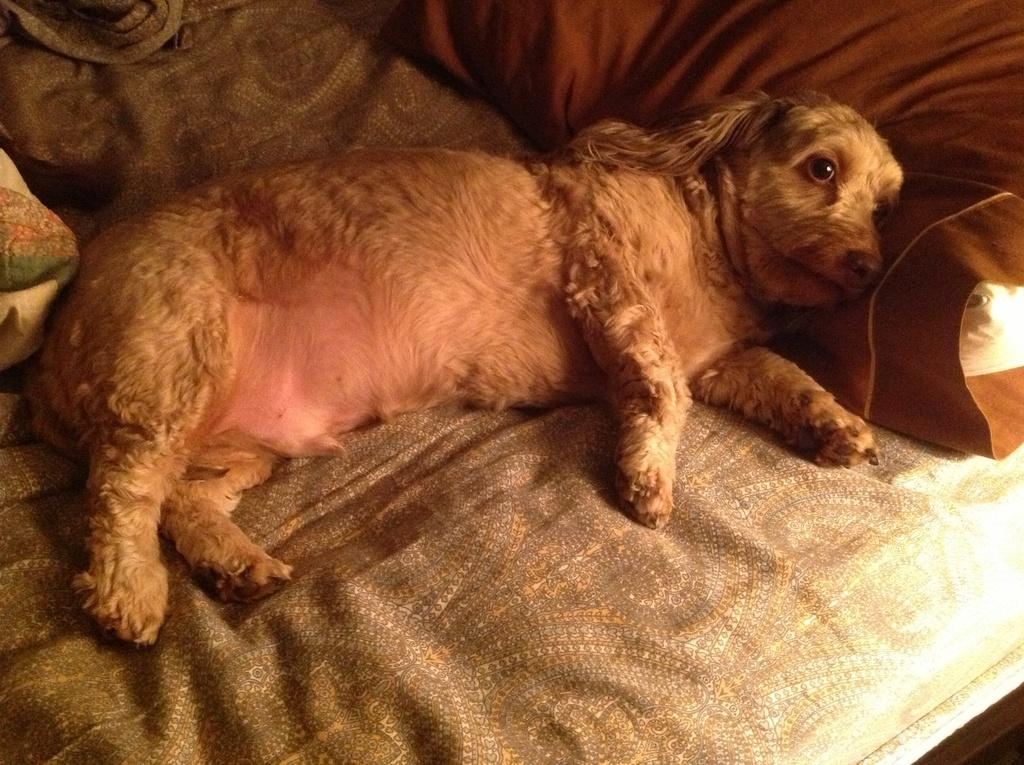What type of animal is present in the image? There is a dog in the image. Where is the dog located in the image? The dog is lying on a sofa. What type of truck is visible in the image? There is no truck present in the image; it features a dog lying on a sofa. What industry is depicted in the image? The image does not depict any industry; it features a dog lying on a sofa. 